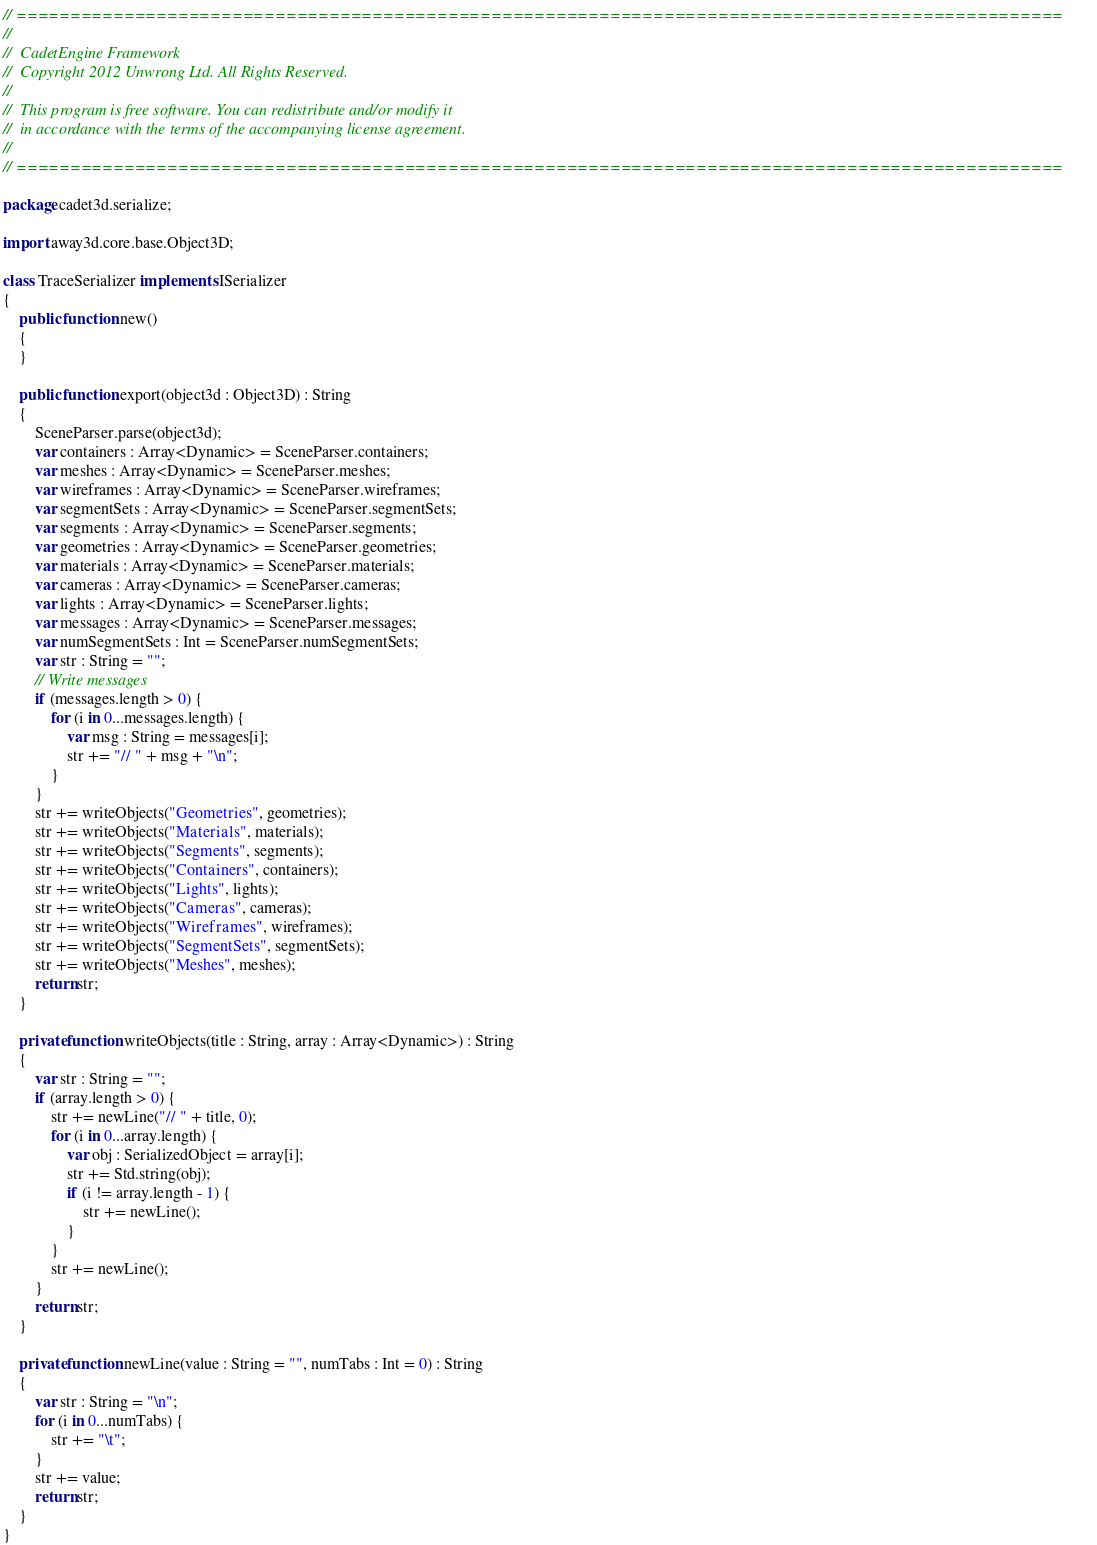<code> <loc_0><loc_0><loc_500><loc_500><_Haxe_>// =================================================================================================    
//    
//	CadetEngine Framework    
//	Copyright 2012 Unwrong Ltd. All Rights Reserved.    
//    
//	This program is free software. You can redistribute and/or modify it    
//	in accordance with the terms of the accompanying license agreement.    
//    
// =================================================================================================  

package cadet3d.serialize;

import away3d.core.base.Object3D;

class TraceSerializer implements ISerializer
{
	public function new()
	{
	}
	
	public function export(object3d : Object3D) : String
	{
		SceneParser.parse(object3d);
		var containers : Array<Dynamic> = SceneParser.containers;
		var meshes : Array<Dynamic> = SceneParser.meshes;
		var wireframes : Array<Dynamic> = SceneParser.wireframes;
		var segmentSets : Array<Dynamic> = SceneParser.segmentSets;
		var segments : Array<Dynamic> = SceneParser.segments;
		var geometries : Array<Dynamic> = SceneParser.geometries;
		var materials : Array<Dynamic> = SceneParser.materials;
		var cameras : Array<Dynamic> = SceneParser.cameras;
		var lights : Array<Dynamic> = SceneParser.lights;
		var messages : Array<Dynamic> = SceneParser.messages;
		var numSegmentSets : Int = SceneParser.numSegmentSets;
		var str : String = "";  
		// Write messages  
		if (messages.length > 0) {
			for (i in 0...messages.length) {
				var msg : String = messages[i];
				str += "// " + msg + "\n";
			}
		}
		str += writeObjects("Geometries", geometries);
		str += writeObjects("Materials", materials);
		str += writeObjects("Segments", segments);
		str += writeObjects("Containers", containers);
		str += writeObjects("Lights", lights);
		str += writeObjects("Cameras", cameras);
		str += writeObjects("Wireframes", wireframes);
		str += writeObjects("SegmentSets", segmentSets);
		str += writeObjects("Meshes", meshes);
		return str;
	}
	
	private function writeObjects(title : String, array : Array<Dynamic>) : String
	{
		var str : String = "";
		if (array.length > 0) {
			str += newLine("// " + title, 0);
			for (i in 0...array.length) {
				var obj : SerializedObject = array[i];
				str += Std.string(obj);
				if (i != array.length - 1) {
					str += newLine();
				}
			}
			str += newLine();
		}
		return str;
	}
	
	private function newLine(value : String = "", numTabs : Int = 0) : String
	{
		var str : String = "\n";
		for (i in 0...numTabs) {
			str += "\t";
		}
		str += value;
		return str;
	}
}</code> 